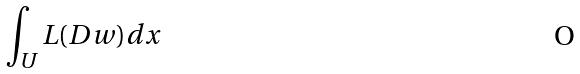Convert formula to latex. <formula><loc_0><loc_0><loc_500><loc_500>\int _ { U } L ( D w ) d x</formula> 